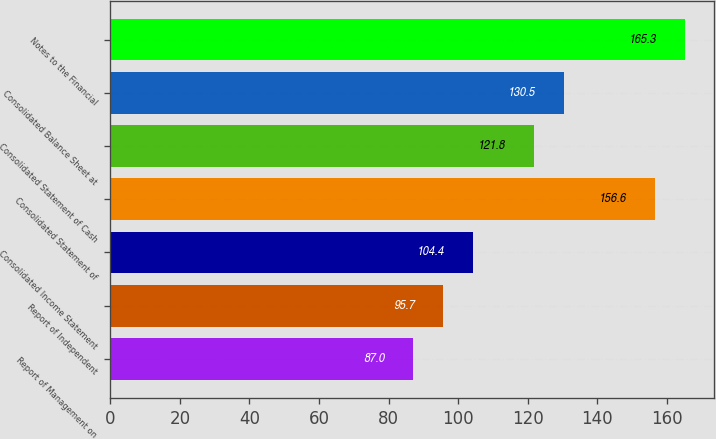Convert chart to OTSL. <chart><loc_0><loc_0><loc_500><loc_500><bar_chart><fcel>Report of Management on<fcel>Report of Independent<fcel>Consolidated Income Statement<fcel>Consolidated Statement of<fcel>Consolidated Statement of Cash<fcel>Consolidated Balance Sheet at<fcel>Notes to the Financial<nl><fcel>87<fcel>95.7<fcel>104.4<fcel>156.6<fcel>121.8<fcel>130.5<fcel>165.3<nl></chart> 